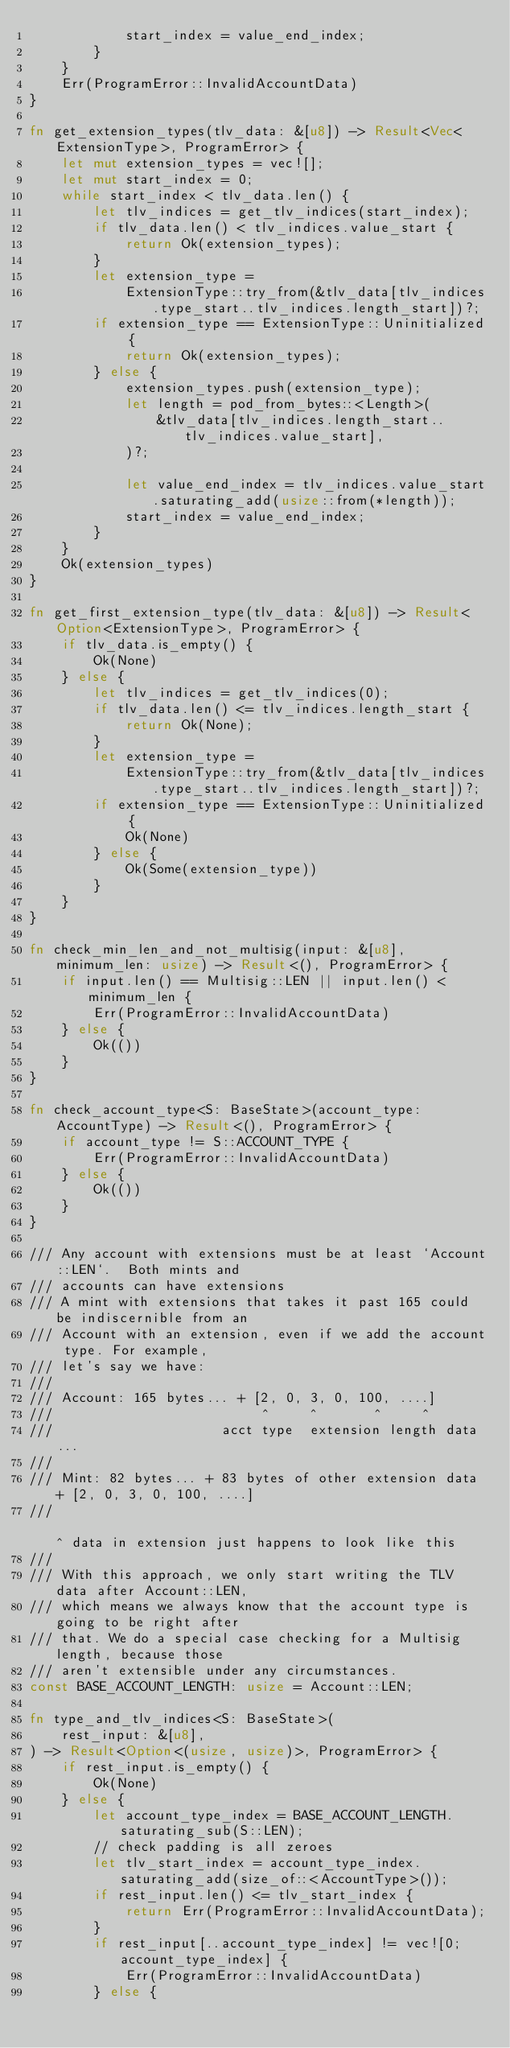Convert code to text. <code><loc_0><loc_0><loc_500><loc_500><_Rust_>            start_index = value_end_index;
        }
    }
    Err(ProgramError::InvalidAccountData)
}

fn get_extension_types(tlv_data: &[u8]) -> Result<Vec<ExtensionType>, ProgramError> {
    let mut extension_types = vec![];
    let mut start_index = 0;
    while start_index < tlv_data.len() {
        let tlv_indices = get_tlv_indices(start_index);
        if tlv_data.len() < tlv_indices.value_start {
            return Ok(extension_types);
        }
        let extension_type =
            ExtensionType::try_from(&tlv_data[tlv_indices.type_start..tlv_indices.length_start])?;
        if extension_type == ExtensionType::Uninitialized {
            return Ok(extension_types);
        } else {
            extension_types.push(extension_type);
            let length = pod_from_bytes::<Length>(
                &tlv_data[tlv_indices.length_start..tlv_indices.value_start],
            )?;

            let value_end_index = tlv_indices.value_start.saturating_add(usize::from(*length));
            start_index = value_end_index;
        }
    }
    Ok(extension_types)
}

fn get_first_extension_type(tlv_data: &[u8]) -> Result<Option<ExtensionType>, ProgramError> {
    if tlv_data.is_empty() {
        Ok(None)
    } else {
        let tlv_indices = get_tlv_indices(0);
        if tlv_data.len() <= tlv_indices.length_start {
            return Ok(None);
        }
        let extension_type =
            ExtensionType::try_from(&tlv_data[tlv_indices.type_start..tlv_indices.length_start])?;
        if extension_type == ExtensionType::Uninitialized {
            Ok(None)
        } else {
            Ok(Some(extension_type))
        }
    }
}

fn check_min_len_and_not_multisig(input: &[u8], minimum_len: usize) -> Result<(), ProgramError> {
    if input.len() == Multisig::LEN || input.len() < minimum_len {
        Err(ProgramError::InvalidAccountData)
    } else {
        Ok(())
    }
}

fn check_account_type<S: BaseState>(account_type: AccountType) -> Result<(), ProgramError> {
    if account_type != S::ACCOUNT_TYPE {
        Err(ProgramError::InvalidAccountData)
    } else {
        Ok(())
    }
}

/// Any account with extensions must be at least `Account::LEN`.  Both mints and
/// accounts can have extensions
/// A mint with extensions that takes it past 165 could be indiscernible from an
/// Account with an extension, even if we add the account type. For example,
/// let's say we have:
///
/// Account: 165 bytes... + [2, 0, 3, 0, 100, ....]
///                          ^     ^       ^     ^
///                     acct type  extension length data...
///
/// Mint: 82 bytes... + 83 bytes of other extension data + [2, 0, 3, 0, 100, ....]
///                                                         ^ data in extension just happens to look like this
///
/// With this approach, we only start writing the TLV data after Account::LEN,
/// which means we always know that the account type is going to be right after
/// that. We do a special case checking for a Multisig length, because those
/// aren't extensible under any circumstances.
const BASE_ACCOUNT_LENGTH: usize = Account::LEN;

fn type_and_tlv_indices<S: BaseState>(
    rest_input: &[u8],
) -> Result<Option<(usize, usize)>, ProgramError> {
    if rest_input.is_empty() {
        Ok(None)
    } else {
        let account_type_index = BASE_ACCOUNT_LENGTH.saturating_sub(S::LEN);
        // check padding is all zeroes
        let tlv_start_index = account_type_index.saturating_add(size_of::<AccountType>());
        if rest_input.len() <= tlv_start_index {
            return Err(ProgramError::InvalidAccountData);
        }
        if rest_input[..account_type_index] != vec![0; account_type_index] {
            Err(ProgramError::InvalidAccountData)
        } else {</code> 